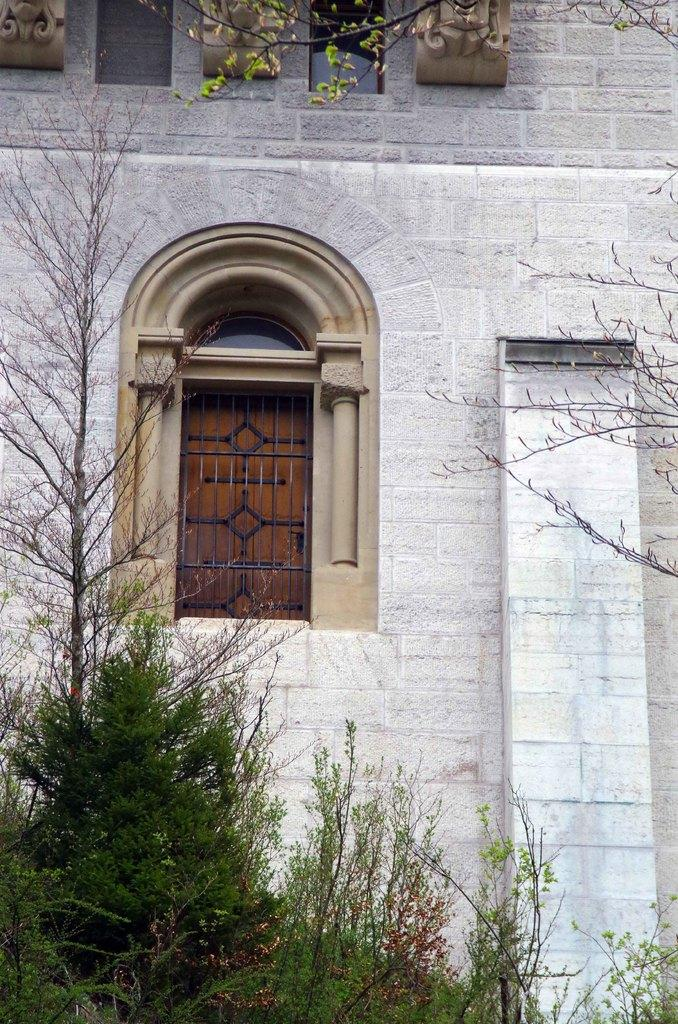What type of vegetation can be seen in the image? There is a group of trees in the image. What architectural feature is visible in the image? There are windows on a wall in the image. What time of day does the image depict, and how does the curve of the sun contribute to the lighting? The provided facts do not mention the time of day or the presence of a curve of the sun, so we cannot determine the lighting or time of day from the image. 